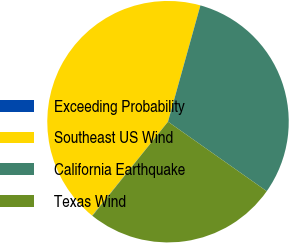Convert chart. <chart><loc_0><loc_0><loc_500><loc_500><pie_chart><fcel>Exceeding Probability<fcel>Southeast US Wind<fcel>California Earthquake<fcel>Texas Wind<nl><fcel>0.05%<fcel>43.51%<fcel>30.44%<fcel>26.0%<nl></chart> 